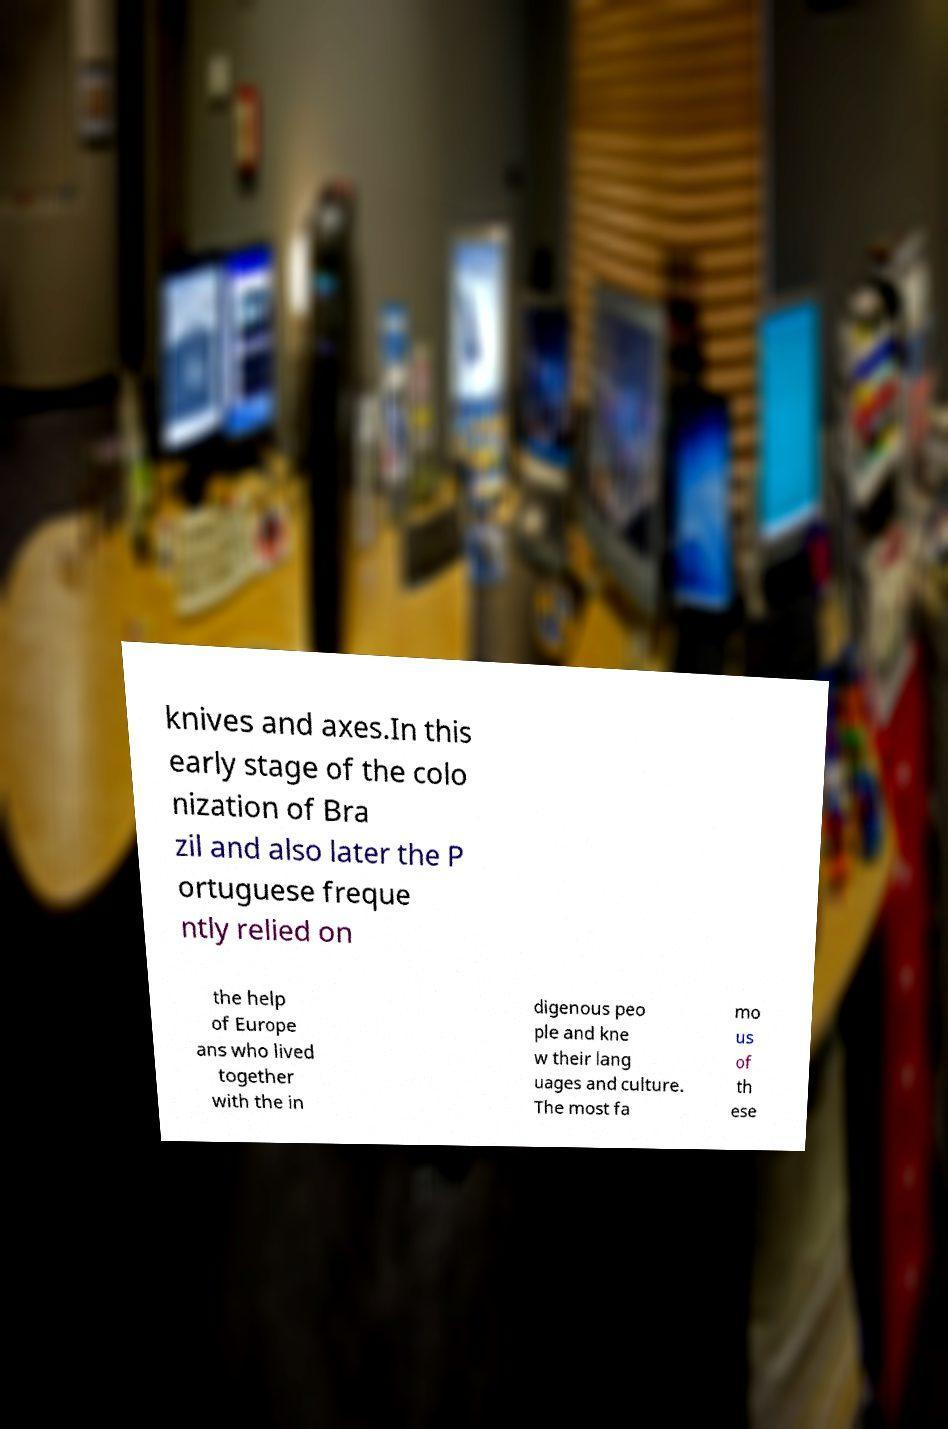I need the written content from this picture converted into text. Can you do that? knives and axes.In this early stage of the colo nization of Bra zil and also later the P ortuguese freque ntly relied on the help of Europe ans who lived together with the in digenous peo ple and kne w their lang uages and culture. The most fa mo us of th ese 